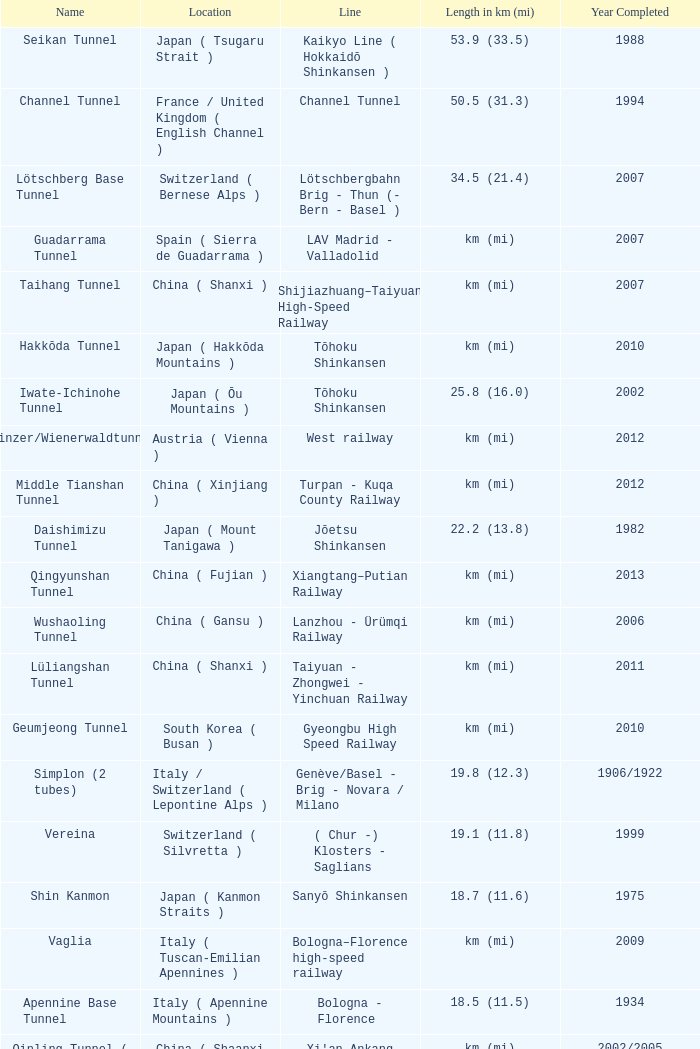Which line is the Geumjeong tunnel? Gyeongbu High Speed Railway. 